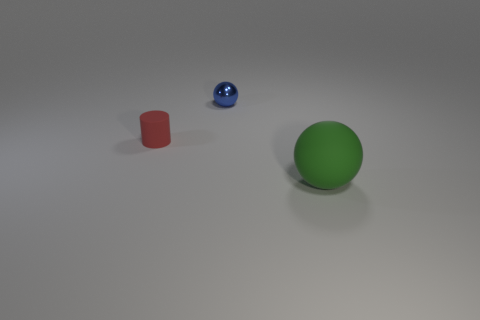What materials are used to create each of the objects in the image? The red cylinder seems to be made of rubber due to its non-reflective, matte surface. The glossy, reflective nature of the blue sphere suggests a polished plastic or glass, and the green sphere looks like it could be made of a matte plastic or ceramic due to its light-diffusing surface. 